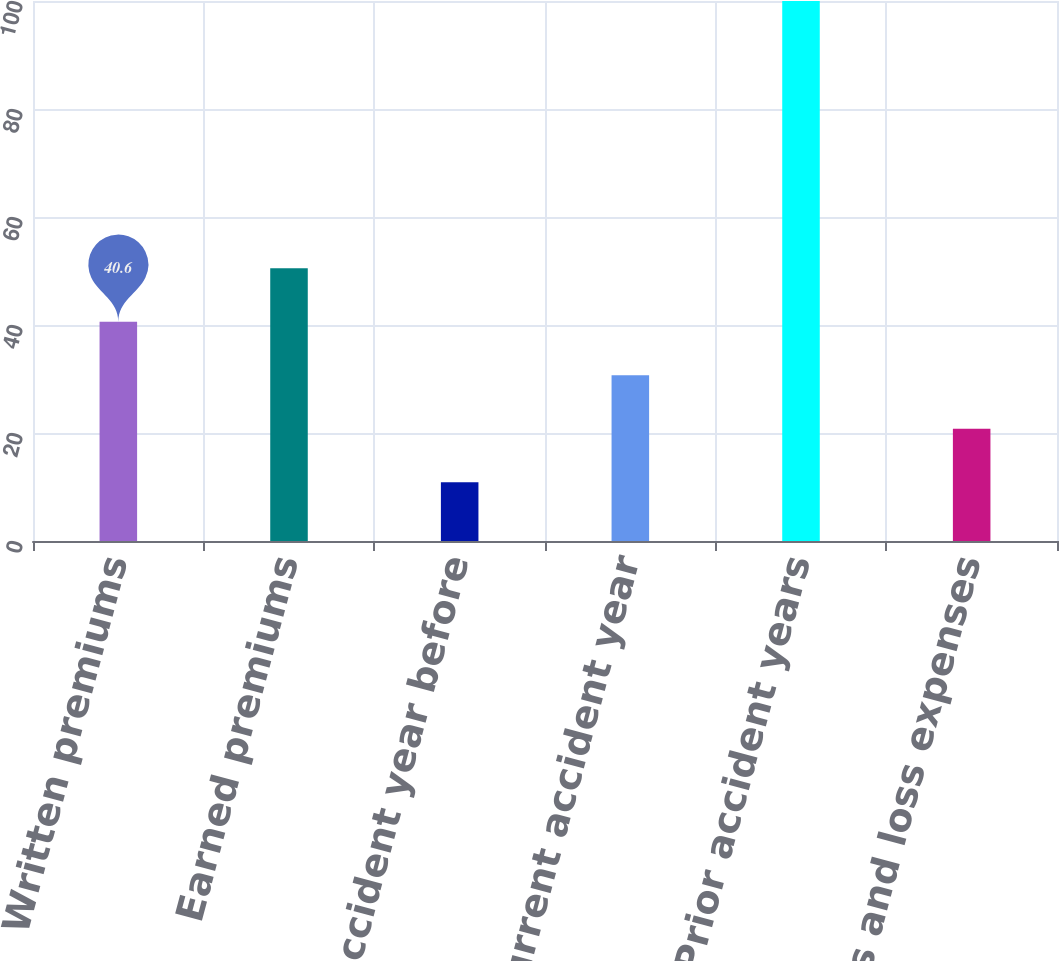Convert chart to OTSL. <chart><loc_0><loc_0><loc_500><loc_500><bar_chart><fcel>Written premiums<fcel>Earned premiums<fcel>Current accident year before<fcel>Current accident year<fcel>Prior accident years<fcel>Total loss and loss expenses<nl><fcel>40.6<fcel>50.5<fcel>10.9<fcel>30.7<fcel>100<fcel>20.8<nl></chart> 